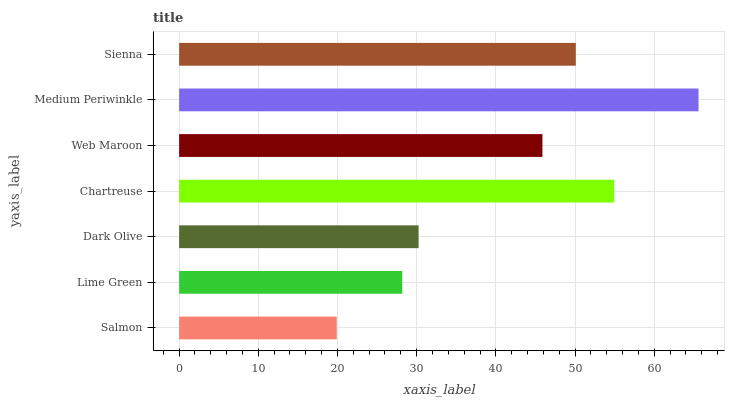Is Salmon the minimum?
Answer yes or no. Yes. Is Medium Periwinkle the maximum?
Answer yes or no. Yes. Is Lime Green the minimum?
Answer yes or no. No. Is Lime Green the maximum?
Answer yes or no. No. Is Lime Green greater than Salmon?
Answer yes or no. Yes. Is Salmon less than Lime Green?
Answer yes or no. Yes. Is Salmon greater than Lime Green?
Answer yes or no. No. Is Lime Green less than Salmon?
Answer yes or no. No. Is Web Maroon the high median?
Answer yes or no. Yes. Is Web Maroon the low median?
Answer yes or no. Yes. Is Sienna the high median?
Answer yes or no. No. Is Lime Green the low median?
Answer yes or no. No. 